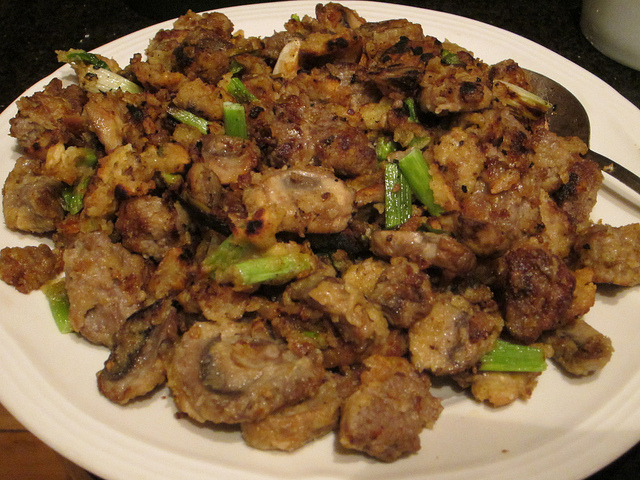<image>What vegetable is in the upper right corner of this photo? I am not sure. There is no vegetable in the upper right corner of this photo. However, it might be an onion, scallion, mushroom, or celery. What vegetable is in the upper right corner of this photo? I am not sure what vegetable is in the upper right corner of the photo. It can be seen 'onion', 'scallion', 'mushroom', 'celery', or any other vegetable. 